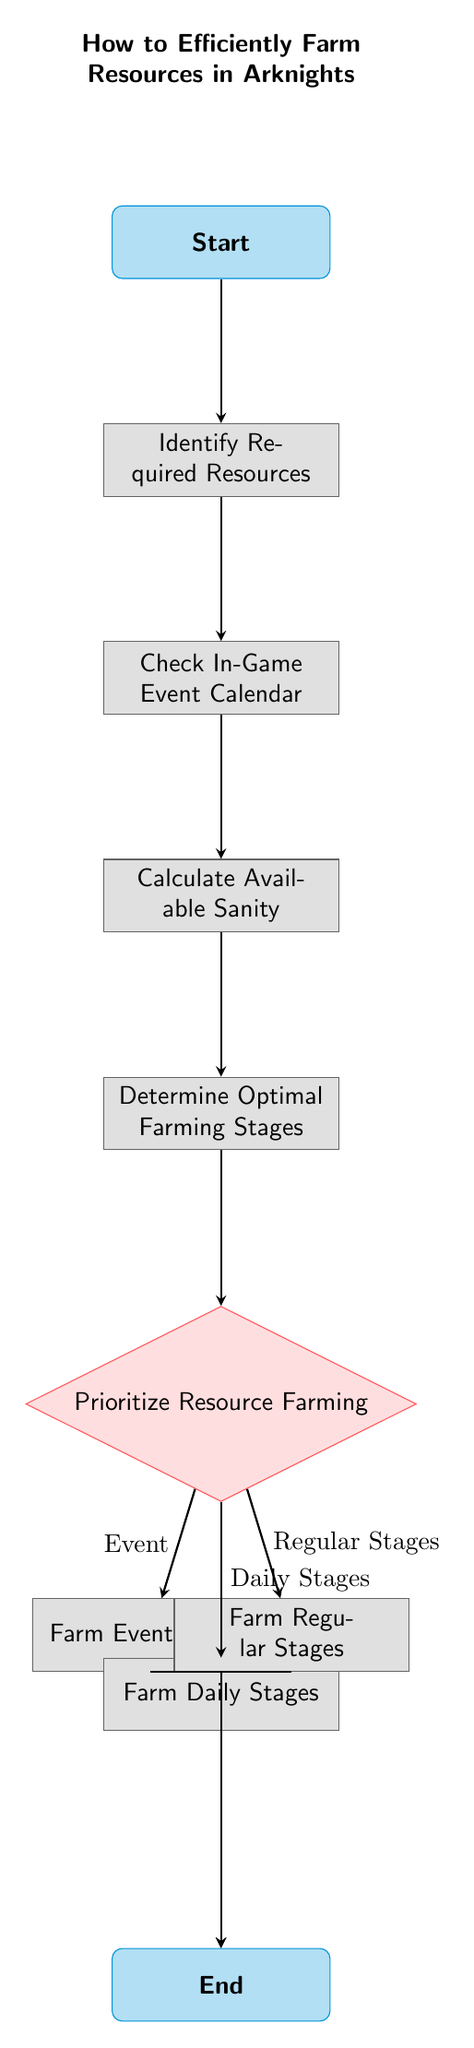What is the first step in the process? The first step in the process is labeled as "Start". It is the initial point of the flow chart where the farming process begins.
Answer: Start How many main farming options are there? From the "Prioritize Resource Farming" decision node, there are three main options: "Farm Event Stages", "Farm Daily Stages", and "Farm Regular Stages". Therefore, the total number of farming options is three.
Answer: Three What comes after "Calculate Available Sanity"? The node that comes directly after "Calculate Available Sanity" is "Determine Optimal Farming Stages". This is the step where players figure out which stages are best for farming.
Answer: Determine Optimal Farming Stages What happens if the player chooses "Event"? If the player selects "Event" from the "Prioritize Resource Farming" decision node, they proceed to the "Farm Event Stages" process. This indicates that the player prioritizes farming during an event.
Answer: Farm Event Stages Which node connects to the end node via "Farm Daily Stages"? The node "Farm Daily Stages" directly connects to the "End" node, indicating that completing this farming option leads to the conclusion of the process.
Answer: Farm Daily Stages What are the three types of farming stages represented in the diagram? The three types of farming stages are represented as "Event", "Daily Stages", and "Regular Stages". These categories help players decide where to focus their farming efforts based on the current game context.
Answer: Event, Daily Stages, Regular Stages What is the last step in this process? The last step in this process is labeled as "End". It signifies the conclusion of the resource farming flow after selecting and completing the respective farming stages.
Answer: End What is the relationship between "Optimal Farming Stages" and "Prioritize Resource Farming"? "Optimal Farming Stages" leads directly to "Prioritize Resource Farming", indicating that players first determine the best stages to farm before making priorities on which to farm based on events, daily, or regular options.
Answer: Leads to 